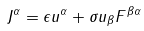Convert formula to latex. <formula><loc_0><loc_0><loc_500><loc_500>J ^ { \alpha } = \epsilon u ^ { \alpha } + \sigma u _ { \beta } F ^ { \beta \alpha }</formula> 